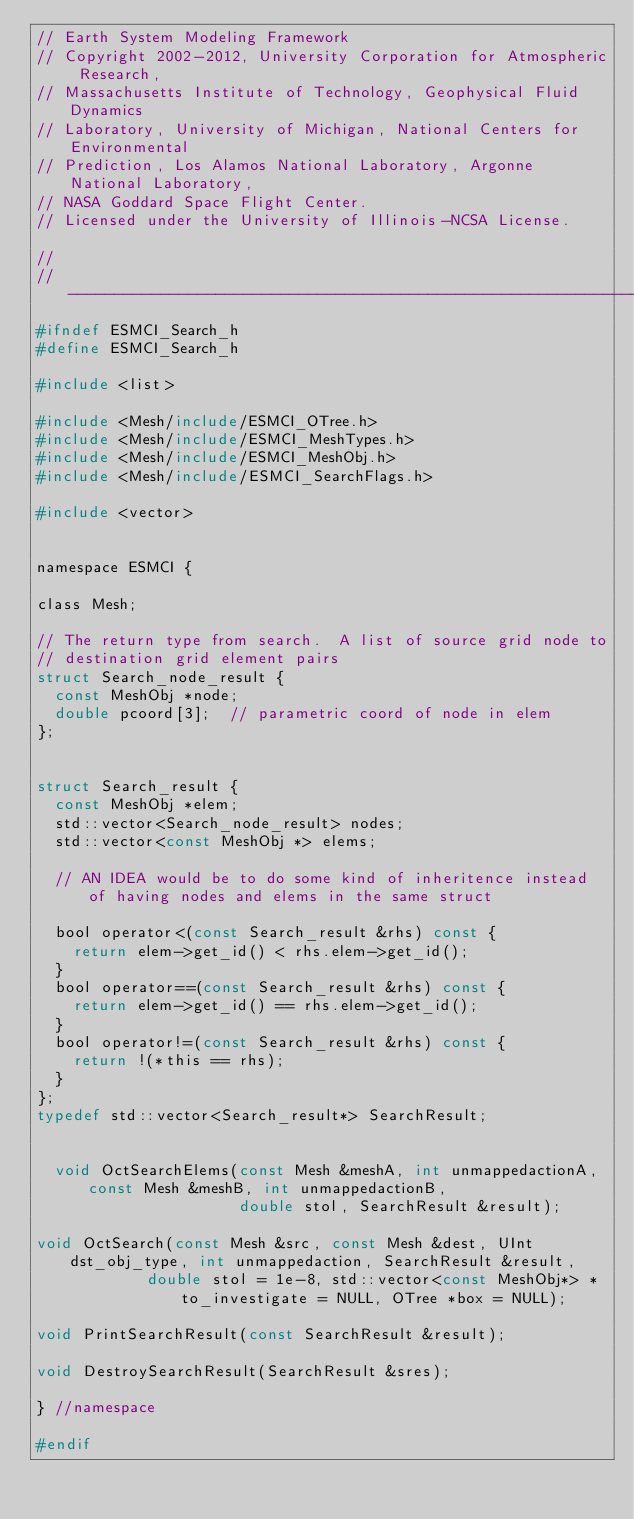Convert code to text. <code><loc_0><loc_0><loc_500><loc_500><_C_>// Earth System Modeling Framework
// Copyright 2002-2012, University Corporation for Atmospheric Research, 
// Massachusetts Institute of Technology, Geophysical Fluid Dynamics 
// Laboratory, University of Michigan, National Centers for Environmental 
// Prediction, Los Alamos National Laboratory, Argonne National Laboratory, 
// NASA Goddard Space Flight Center.
// Licensed under the University of Illinois-NCSA License.

//
//-----------------------------------------------------------------------------
#ifndef ESMCI_Search_h
#define ESMCI_Search_h

#include <list>

#include <Mesh/include/ESMCI_OTree.h>
#include <Mesh/include/ESMCI_MeshTypes.h>
#include <Mesh/include/ESMCI_MeshObj.h>
#include <Mesh/include/ESMCI_SearchFlags.h>

#include <vector>


namespace ESMCI {

class Mesh;

// The return type from search.  A list of source grid node to
// destination grid element pairs
struct Search_node_result {
  const MeshObj *node;
  double pcoord[3];  // parametric coord of node in elem
};


struct Search_result {
  const MeshObj *elem;
  std::vector<Search_node_result> nodes;
  std::vector<const MeshObj *> elems;

  // AN IDEA would be to do some kind of inheritence instead of having nodes and elems in the same struct

  bool operator<(const Search_result &rhs) const {
    return elem->get_id() < rhs.elem->get_id();
  }
  bool operator==(const Search_result &rhs) const {
    return elem->get_id() == rhs.elem->get_id();
  }
  bool operator!=(const Search_result &rhs) const {
    return !(*this == rhs);
  }
};
typedef std::vector<Search_result*> SearchResult;


  void OctSearchElems(const Mesh &meshA, int unmappedactionA, const Mesh &meshB, int unmappedactionB, 
                      double stol, SearchResult &result);

void OctSearch(const Mesh &src, const Mesh &dest, UInt dst_obj_type, int unmappedaction, SearchResult &result,
            double stol = 1e-8, std::vector<const MeshObj*> *to_investigate = NULL, OTree *box = NULL);

void PrintSearchResult(const SearchResult &result);

void DestroySearchResult(SearchResult &sres);

} //namespace

#endif
</code> 